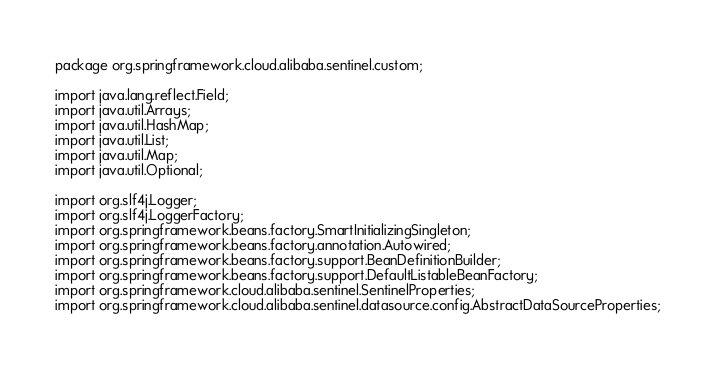<code> <loc_0><loc_0><loc_500><loc_500><_Java_>package org.springframework.cloud.alibaba.sentinel.custom;

import java.lang.reflect.Field;
import java.util.Arrays;
import java.util.HashMap;
import java.util.List;
import java.util.Map;
import java.util.Optional;

import org.slf4j.Logger;
import org.slf4j.LoggerFactory;
import org.springframework.beans.factory.SmartInitializingSingleton;
import org.springframework.beans.factory.annotation.Autowired;
import org.springframework.beans.factory.support.BeanDefinitionBuilder;
import org.springframework.beans.factory.support.DefaultListableBeanFactory;
import org.springframework.cloud.alibaba.sentinel.SentinelProperties;
import org.springframework.cloud.alibaba.sentinel.datasource.config.AbstractDataSourceProperties;</code> 